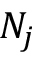<formula> <loc_0><loc_0><loc_500><loc_500>N _ { j }</formula> 